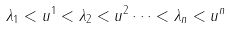<formula> <loc_0><loc_0><loc_500><loc_500>\lambda _ { 1 } < u ^ { 1 } < \lambda _ { 2 } < u ^ { 2 } \cdots < \lambda _ { n } < u ^ { n }</formula> 